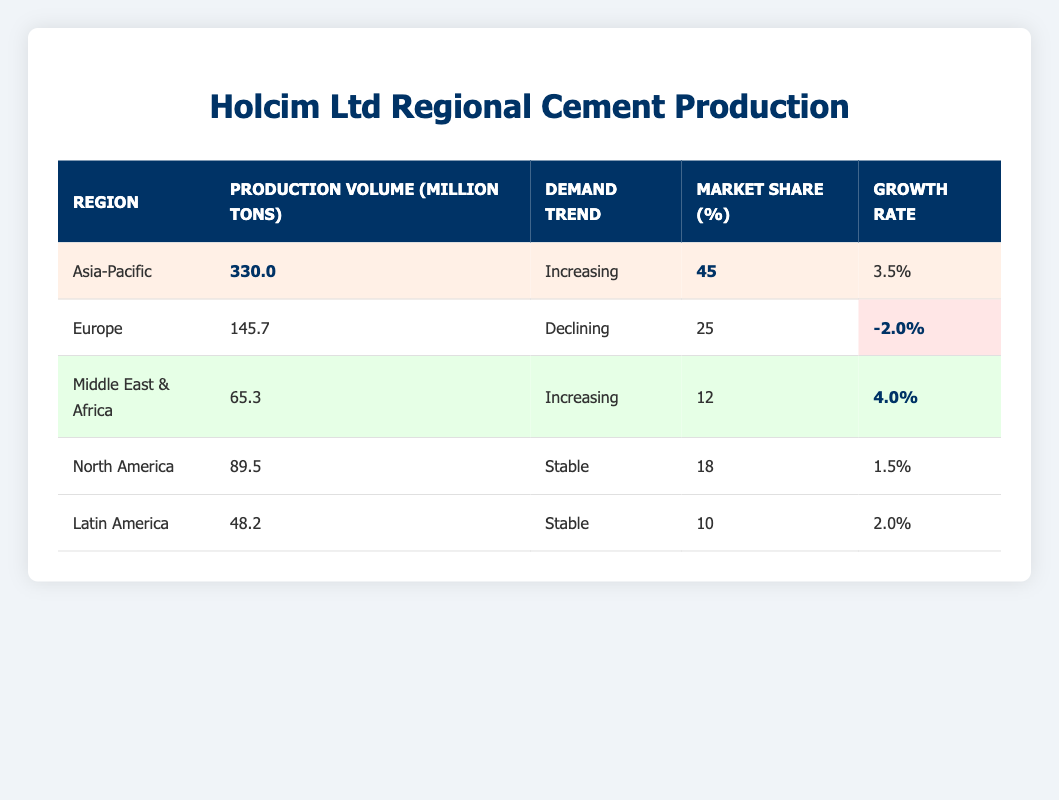What is the production volume in the Asia-Pacific region? The table lists the Asia-Pacific region with a production volume of 330.0 million tons.
Answer: 330.0 million tons Which region has the highest market share? The Asia-Pacific region has the highest market share at 45%.
Answer: 45% Is the growth rate for Europe positive or negative? The growth rate for Europe is listed as -2.0%, which is negative.
Answer: Negative What is the total production volume for North America and Latin America combined? North America has 89.5 million tons and Latin America has 48.2 million tons. Summing these gives 89.5 + 48.2 = 137.7 million tons.
Answer: 137.7 million tons Which region shows a stable demand trend and has a growth rate of at least 2%? The table lists North America and Latin America as stable, but only Latin America has a growth rate of 2.0%, while North America has 1.5%. So only Latin America meets both criteria.
Answer: Latin America How does the growth rate of the Middle East & Africa compare to that of North America? The Middle East & Africa has a growth rate of 4.0%, while North America has a growth rate of 1.5%. Therefore, Middle East & Africa's growth rate is higher.
Answer: Higher What is the average growth rate of all the regions listed in the table? The growth rates are 1.5%, -2.0%, 3.5%, 2.0%, and 4.0%. The sum is 1.5 + (-2.0) + 3.5 + 2.0 + 4.0 = 9.0. With 5 regions, the average is 9.0 / 5 = 1.8%.
Answer: 1.8% Does any region have a growth rate greater than 3%? The regions are: Asia-Pacific (3.5%), Latin America (2.0%), Middle East & Africa (4.0%). Both Asia-Pacific and Middle East & Africa have growth rates over 3%.
Answer: Yes Which region has declining demand and what is its production volume? Europe has a declining demand trend, with a production volume of 145.7 million tons.
Answer: Europe, 145.7 million tons If the Asia-Pacific region's growth rate increases to 5%, how would it compare to the growth rate of Middle East & Africa? Currently, Middle East & Africa has a growth rate of 4.0%. If Asia-Pacific's growth rate is increased to 5%, then it would be higher than Middle East & Africa's growth rate.
Answer: Asia-Pacific would be higher 